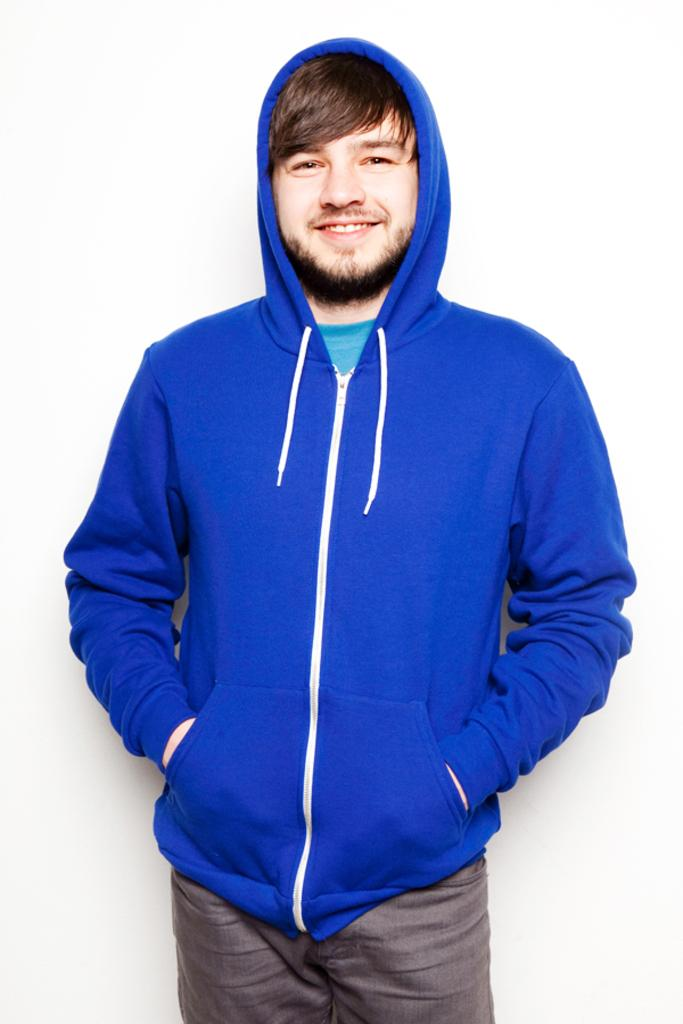Who is present in the image? There is a man in the image. What is the man doing in the image? The man is standing. How many lizards can be seen on the man's tongue in the image? There are no lizards present in the image, and the man's tongue is not visible. 